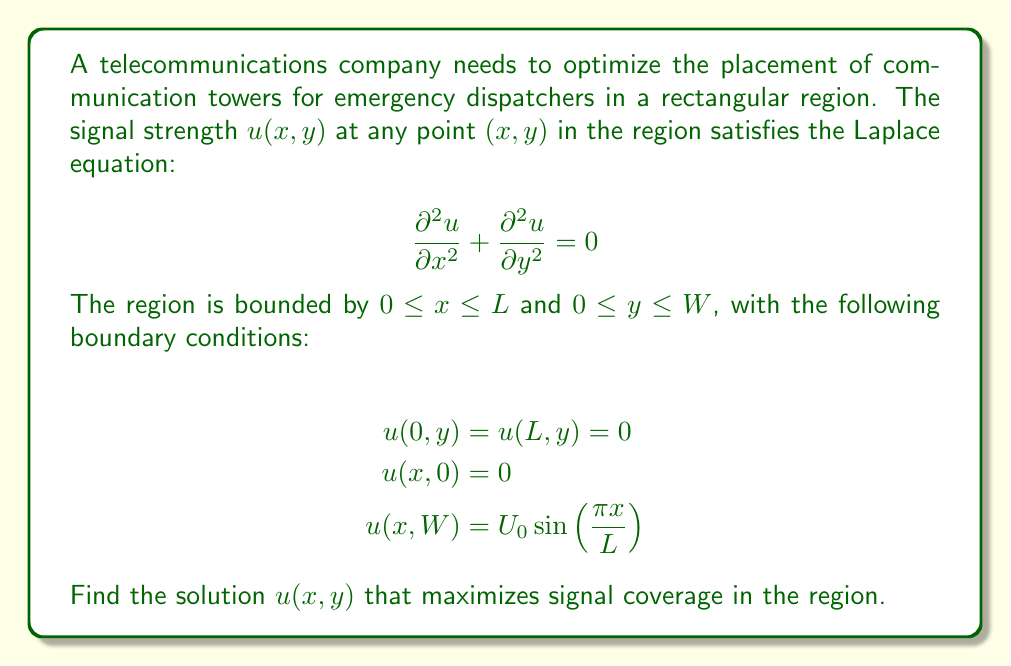Give your solution to this math problem. To solve this problem, we'll use the method of separation of variables:

1) Assume the solution has the form $u(x,y) = X(x)Y(y)$.

2) Substitute this into the Laplace equation:
   $$X''(x)Y(y) + X(x)Y''(y) = 0$$
   $$\frac{X''(x)}{X(x)} = -\frac{Y''(y)}{Y(y)} = -k^2$$

3) This gives us two ordinary differential equations:
   $$X''(x) + k^2X(x) = 0$$
   $$Y''(y) - k^2Y(y) = 0$$

4) The general solutions are:
   $$X(x) = A\sin(kx) + B\cos(kx)$$
   $$Y(y) = Ce^{ky} + De^{-ky}$$

5) Apply the boundary conditions:
   - $u(0,y) = u(L,y) = 0$ implies $B = 0$ and $k = \frac{n\pi}{L}$ for $n = 1,2,3,...$
   - $u(x,0) = 0$ implies $C = -D$

6) The solution now has the form:
   $$u(x,y) = \sum_{n=1}^{\infty} A_n \sin(\frac{n\pi x}{L}) \sinh(\frac{n\pi y}{L})$$

7) Apply the final boundary condition:
   $$u(x,W) = U_0 \sin(\frac{\pi x}{L}) = \sum_{n=1}^{\infty} A_n \sin(\frac{n\pi x}{L}) \sinh(\frac{n\pi W}{L})$$

8) This implies that only the $n=1$ term is non-zero, and:
   $$A_1 = \frac{U_0}{\sinh(\frac{\pi W}{L})}$$

Therefore, the final solution is:

$$u(x,y) = \frac{U_0 \sinh(\frac{\pi y}{L})}{\sinh(\frac{\pi W}{L})} \sin(\frac{\pi x}{L})$$

This solution maximizes signal coverage by providing a smooth distribution of signal strength across the region, with the strongest signal at the top boundary.
Answer: $$u(x,y) = \frac{U_0 \sinh(\frac{\pi y}{L})}{\sinh(\frac{\pi W}{L})} \sin(\frac{\pi x}{L})$$ 